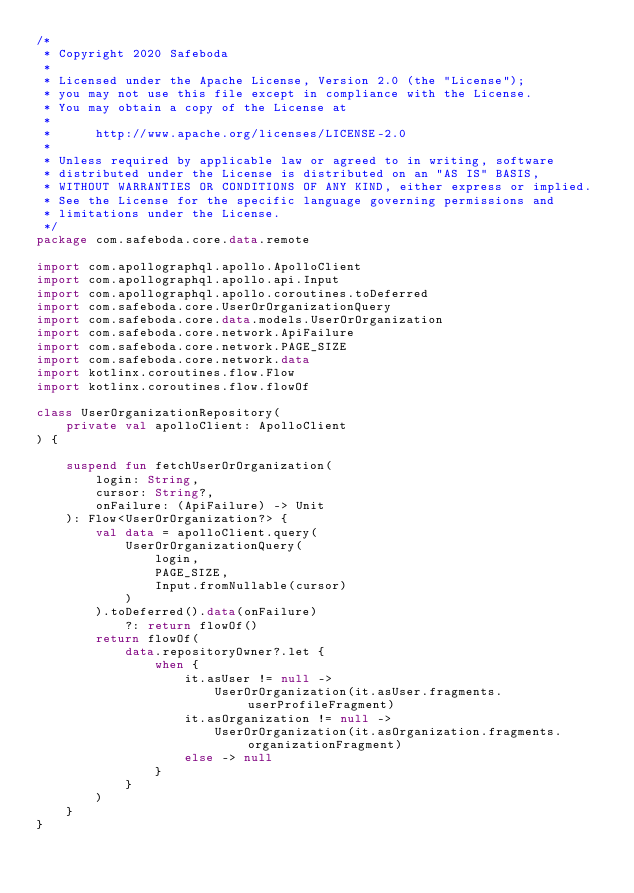<code> <loc_0><loc_0><loc_500><loc_500><_Kotlin_>/*
 * Copyright 2020 Safeboda
 *
 * Licensed under the Apache License, Version 2.0 (the "License");
 * you may not use this file except in compliance with the License.
 * You may obtain a copy of the License at
 *
 *      http://www.apache.org/licenses/LICENSE-2.0
 *
 * Unless required by applicable law or agreed to in writing, software
 * distributed under the License is distributed on an "AS IS" BASIS,
 * WITHOUT WARRANTIES OR CONDITIONS OF ANY KIND, either express or implied.
 * See the License for the specific language governing permissions and
 * limitations under the License.
 */
package com.safeboda.core.data.remote

import com.apollographql.apollo.ApolloClient
import com.apollographql.apollo.api.Input
import com.apollographql.apollo.coroutines.toDeferred
import com.safeboda.core.UserOrOrganizationQuery
import com.safeboda.core.data.models.UserOrOrganization
import com.safeboda.core.network.ApiFailure
import com.safeboda.core.network.PAGE_SIZE
import com.safeboda.core.network.data
import kotlinx.coroutines.flow.Flow
import kotlinx.coroutines.flow.flowOf

class UserOrganizationRepository(
    private val apolloClient: ApolloClient
) {

    suspend fun fetchUserOrOrganization(
        login: String,
        cursor: String?,
        onFailure: (ApiFailure) -> Unit
    ): Flow<UserOrOrganization?> {
        val data = apolloClient.query(
            UserOrOrganizationQuery(
                login,
                PAGE_SIZE,
                Input.fromNullable(cursor)
            )
        ).toDeferred().data(onFailure)
            ?: return flowOf()
        return flowOf(
            data.repositoryOwner?.let {
                when {
                    it.asUser != null ->
                        UserOrOrganization(it.asUser.fragments.userProfileFragment)
                    it.asOrganization != null ->
                        UserOrOrganization(it.asOrganization.fragments.organizationFragment)
                    else -> null
                }
            }
        )
    }
}</code> 